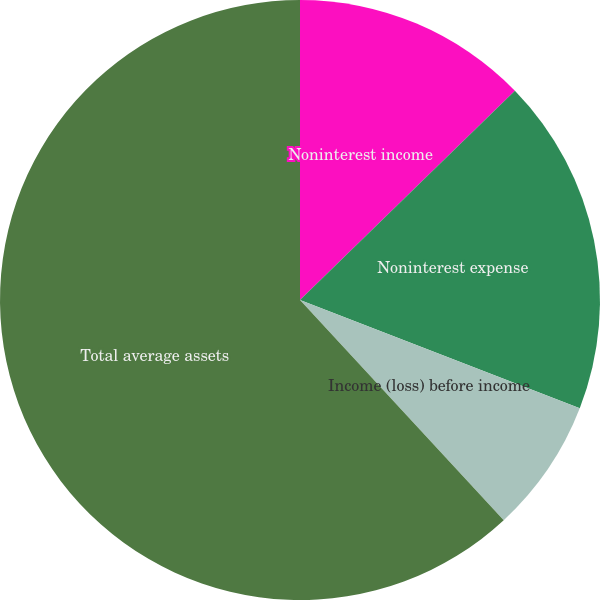Convert chart. <chart><loc_0><loc_0><loc_500><loc_500><pie_chart><fcel>Noninterest income<fcel>Noninterest expense<fcel>Income (loss) before income<fcel>Total average assets<nl><fcel>12.71%<fcel>18.17%<fcel>7.24%<fcel>61.88%<nl></chart> 